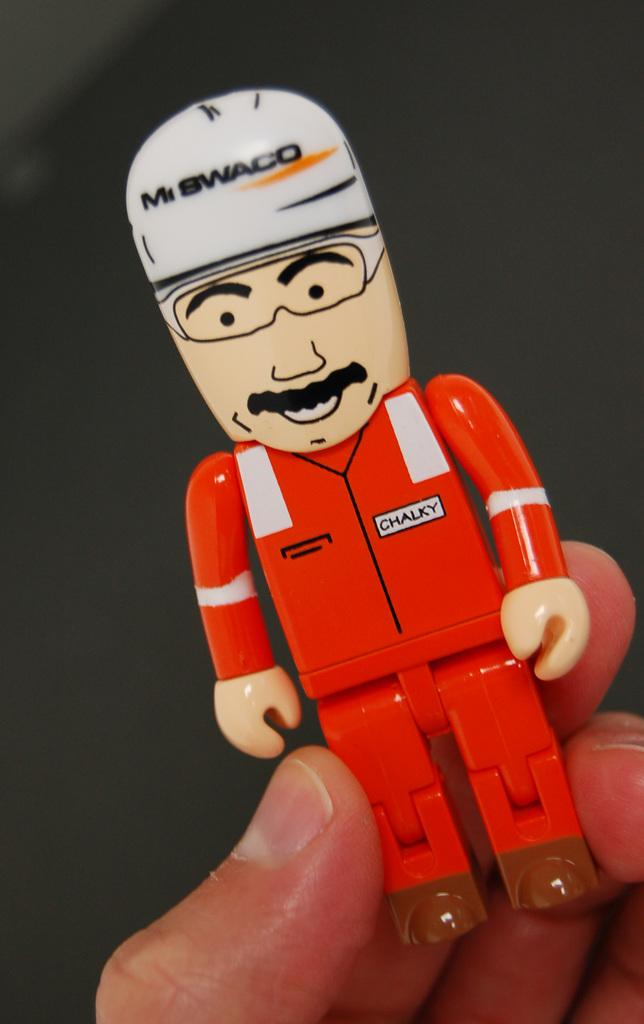What is being held by the person's hand in the image? There is a person's hand holding a doll in the image. What color is the doll? The doll is red in color. What type of accessory does the doll have? The doll has a white cap. What type of rings can be seen on the doll's fingers in the image? There are no rings visible on the doll's fingers in the image, as the doll does not have fingers or any rings. 